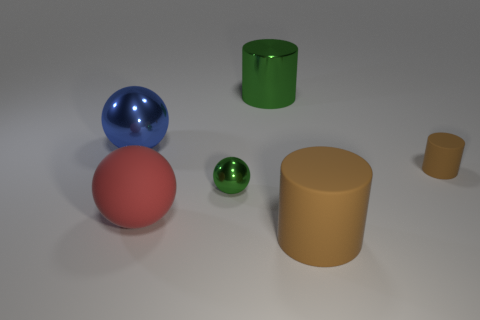Are there any shadows present that indicate the direction of the light source? Yes, there are shadows visible in the image extending to the right of the objects which suggest that the primary light source is to the left. The shadows are soft-edged, indicating the light source is not too harsh and may be diffused, possibly representing a lightbox or a cloudy day if this were an outdoor setting. 